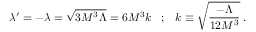Convert formula to latex. <formula><loc_0><loc_0><loc_500><loc_500>\lambda ^ { \prime } = - \lambda = \sqrt { 3 M ^ { 3 } \Lambda } = 6 M ^ { 3 } k \, ; \, k \equiv \sqrt { \frac { - \Lambda } { 1 2 M ^ { 3 } } } \, .</formula> 